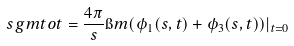Convert formula to latex. <formula><loc_0><loc_0><loc_500><loc_500>\ s g m t o t = \frac { 4 \pi } { s } \i m ( \phi _ { 1 } ( s , t ) + \phi _ { 3 } ( s , t ) ) | _ { t = 0 }</formula> 